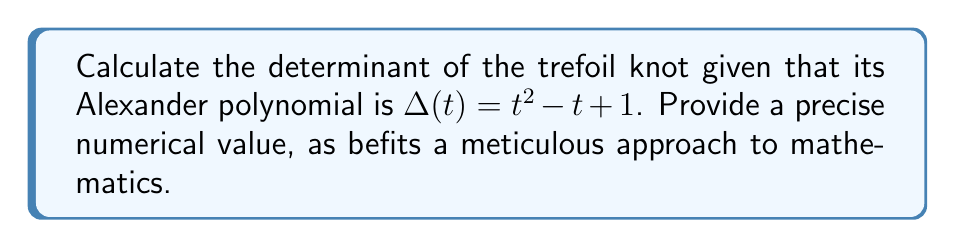Can you answer this question? To solve this problem, we shall proceed with utmost precision:

1) The relationship between the Alexander polynomial and the determinant of a knot is given by:
   $$ \det(K) = |\Delta(-1)| $$
   where $\det(K)$ is the determinant of the knot and $\Delta(t)$ is the Alexander polynomial.

2) We are given that the Alexander polynomial of the trefoil knot is:
   $$ \Delta(t) = t^2 - t + 1 $$

3) To find the determinant, we need to evaluate $\Delta(-1)$:
   $$ \Delta(-1) = (-1)^2 - (-1) + 1 $$

4) Let's calculate this step-by-step:
   $$ \Delta(-1) = 1 + 1 + 1 = 3 $$

5) The determinant is the absolute value of this result:
   $$ \det(K) = |\Delta(-1)| = |3| = 3 $$

Therefore, the determinant of the trefoil knot is precisely 3.
Answer: 3 